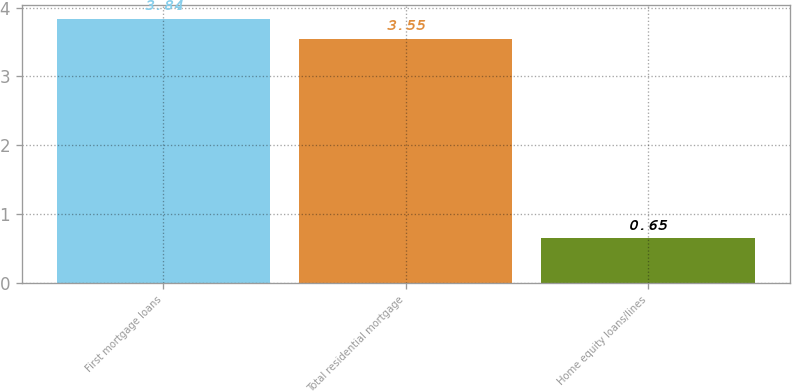Convert chart to OTSL. <chart><loc_0><loc_0><loc_500><loc_500><bar_chart><fcel>First mortgage loans<fcel>Total residential mortgage<fcel>Home equity loans/lines<nl><fcel>3.84<fcel>3.55<fcel>0.65<nl></chart> 